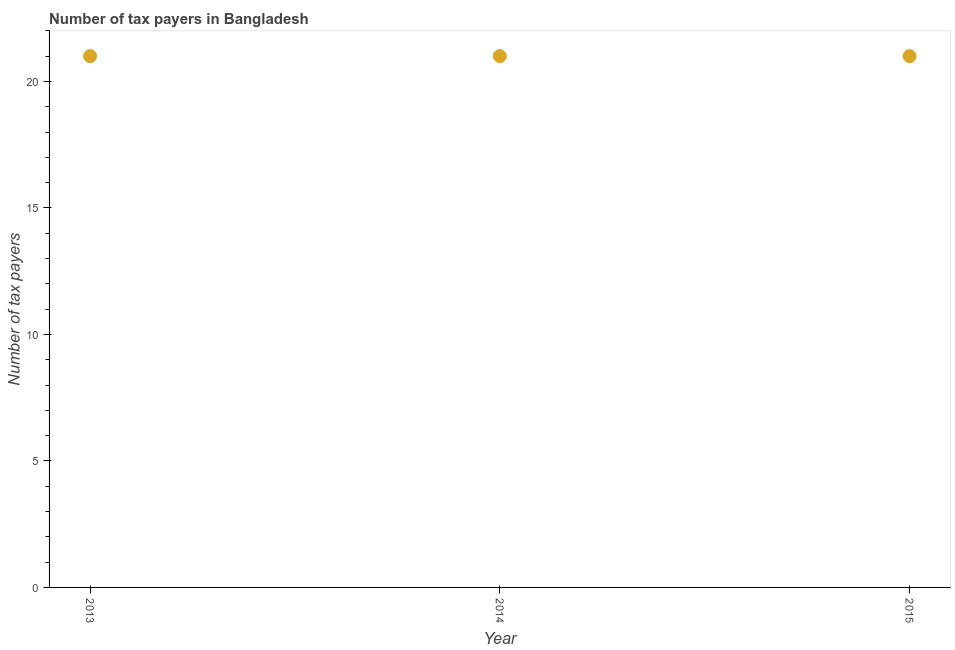What is the number of tax payers in 2015?
Offer a terse response. 21. Across all years, what is the maximum number of tax payers?
Your response must be concise. 21. Across all years, what is the minimum number of tax payers?
Ensure brevity in your answer.  21. In which year was the number of tax payers minimum?
Provide a short and direct response. 2013. What is the sum of the number of tax payers?
Make the answer very short. 63. What is the average number of tax payers per year?
Offer a terse response. 21. In how many years, is the number of tax payers greater than 5 ?
Give a very brief answer. 3. What is the ratio of the number of tax payers in 2013 to that in 2014?
Make the answer very short. 1. What is the difference between the highest and the second highest number of tax payers?
Ensure brevity in your answer.  0. Is the sum of the number of tax payers in 2014 and 2015 greater than the maximum number of tax payers across all years?
Your answer should be compact. Yes. In how many years, is the number of tax payers greater than the average number of tax payers taken over all years?
Make the answer very short. 0. Does the number of tax payers monotonically increase over the years?
Your response must be concise. No. How many dotlines are there?
Offer a terse response. 1. Are the values on the major ticks of Y-axis written in scientific E-notation?
Make the answer very short. No. What is the title of the graph?
Your response must be concise. Number of tax payers in Bangladesh. What is the label or title of the X-axis?
Make the answer very short. Year. What is the label or title of the Y-axis?
Your response must be concise. Number of tax payers. What is the Number of tax payers in 2014?
Make the answer very short. 21. What is the difference between the Number of tax payers in 2013 and 2015?
Offer a very short reply. 0. What is the difference between the Number of tax payers in 2014 and 2015?
Your answer should be very brief. 0. What is the ratio of the Number of tax payers in 2013 to that in 2014?
Your answer should be compact. 1. What is the ratio of the Number of tax payers in 2014 to that in 2015?
Make the answer very short. 1. 